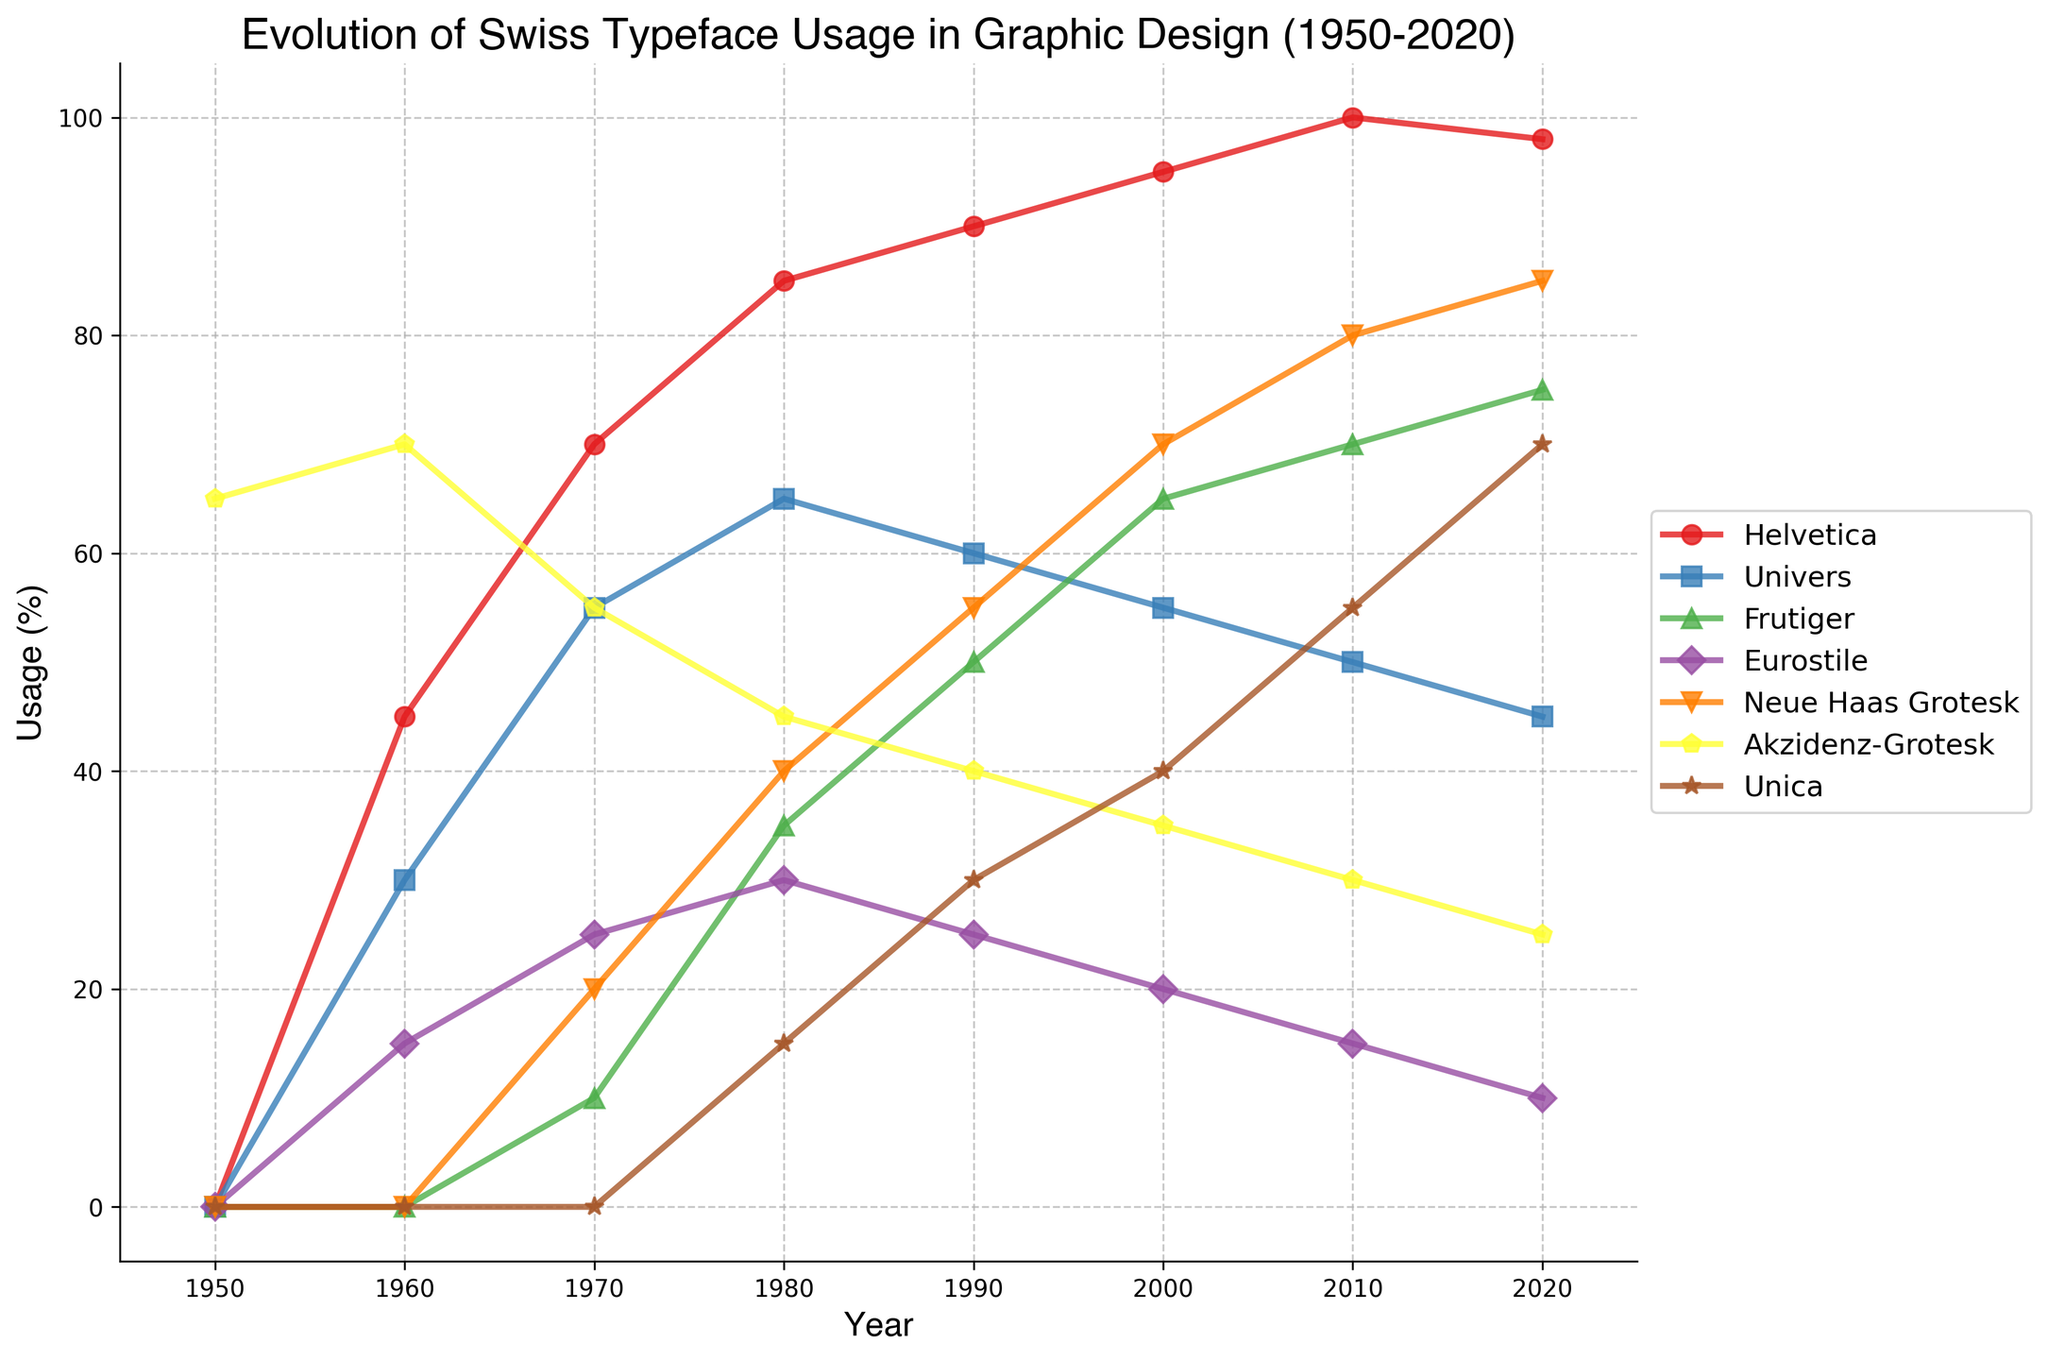Which typeface had the highest usage in 1980? The figure shows the percentage usage of each typeface through the years. In 1980, Helvetica has the highest value, as it reaches 85%.
Answer: Helvetica Did Neue Haas Grotesk's usage ever surpass Helvetica's between 1950 and 2020? By observing the lines representing Neue Haas Grotesk and Helvetica, we see that Neue Haas Grotesk never exceeds Helvetica at any point. Helvetica consistently remains higher.
Answer: No Which two typefaces had the closest usage percentages in 2010? Looking at the 2010 section of the figure, Univers and Neue Haas Grotesk have very close usage percentages at 50% and 55%, respectively.
Answer: Univers and Neue Haas Grotesk How much did the usage of Akzidenz-Grotesk decrease from 1960 to 2020? The figure shows Akzidenz-Grotesk at 70% in 1960 and at 25% in 2020. The decrease in usage is calculated as 70% - 25% = 45%.
Answer: 45% Which typeface showed the largest increase in usage from 1950 to 2020? By comparing the figure lines between 1950 and 2020, Helvetica increased from 0% usage in 1950 to 98% in 2020. This shows a large increase of 98%.
Answer: Helvetica What is the trend in Eurostile usage from 1960 to 2020? Eurostile starts at 15% in 1960, then gradually decreases through the years to 10% in 2020, showing a downward trend overall.
Answer: Downward Between 2000 and 2010, which typeface experienced the largest drop in usage percentage? By looking closely at the lines, Univers drops from 55% in 2000 to 50% in 2010, experiencing the largest drop of 5%.
Answer: Univers Which typeface had zero usage in the 1950s and showed a significant increase by 2020? In 1950, both Helvetica and Frutiger show 0%. By 2020, Helvetica reaches 98%, and Frutiger reaches 75%. Both increased significantly, but Helvetica's increase is more notable.
Answer: Helvetica Calculate the average usage of Frutiger from 1980 to 2020. Checking the values for Frutiger at each decade: 1980 - 35%, 1990 - 50%, 2000 - 65%, 2010 - 70%, 2020 - 75%. The average is (35% + 50% + 65% + 70% + 75%) / 5 = 59%.
Answer: 59% 